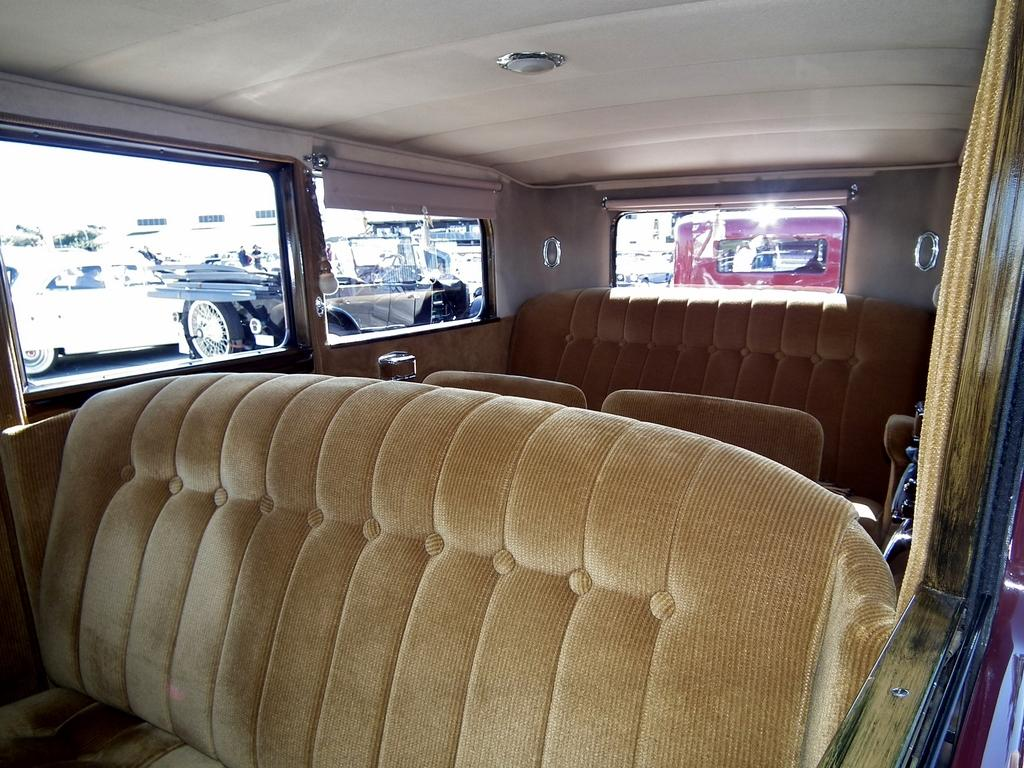What type of space is depicted in the image? The image shows the interior of a vehicle. What can be found inside the vehicle? There are seats in the vehicle. What feature allows passengers to see outside the vehicle? There are glass windows in the vehicle. What can be seen through the windows? Other vehicles and buildings are visible through the windows. What type of roof can be seen on the other vehicles visible through the windows? There is no specific roof type mentioned or visible in the image; only the vehicles and buildings are visible through the windows. 